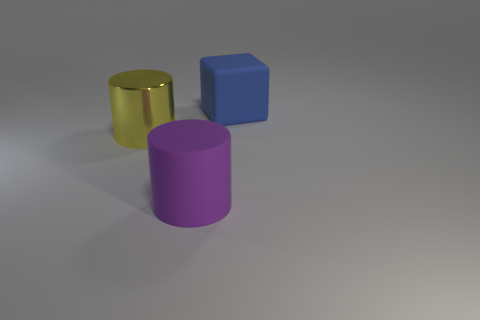Add 1 purple balls. How many objects exist? 4 Subtract all purple cylinders. How many cylinders are left? 1 Subtract all cubes. How many objects are left? 2 Subtract all large matte cylinders. Subtract all blue things. How many objects are left? 1 Add 1 large rubber cubes. How many large rubber cubes are left? 2 Add 1 tiny cyan matte objects. How many tiny cyan matte objects exist? 1 Subtract 0 green blocks. How many objects are left? 3 Subtract all brown cylinders. Subtract all green spheres. How many cylinders are left? 2 